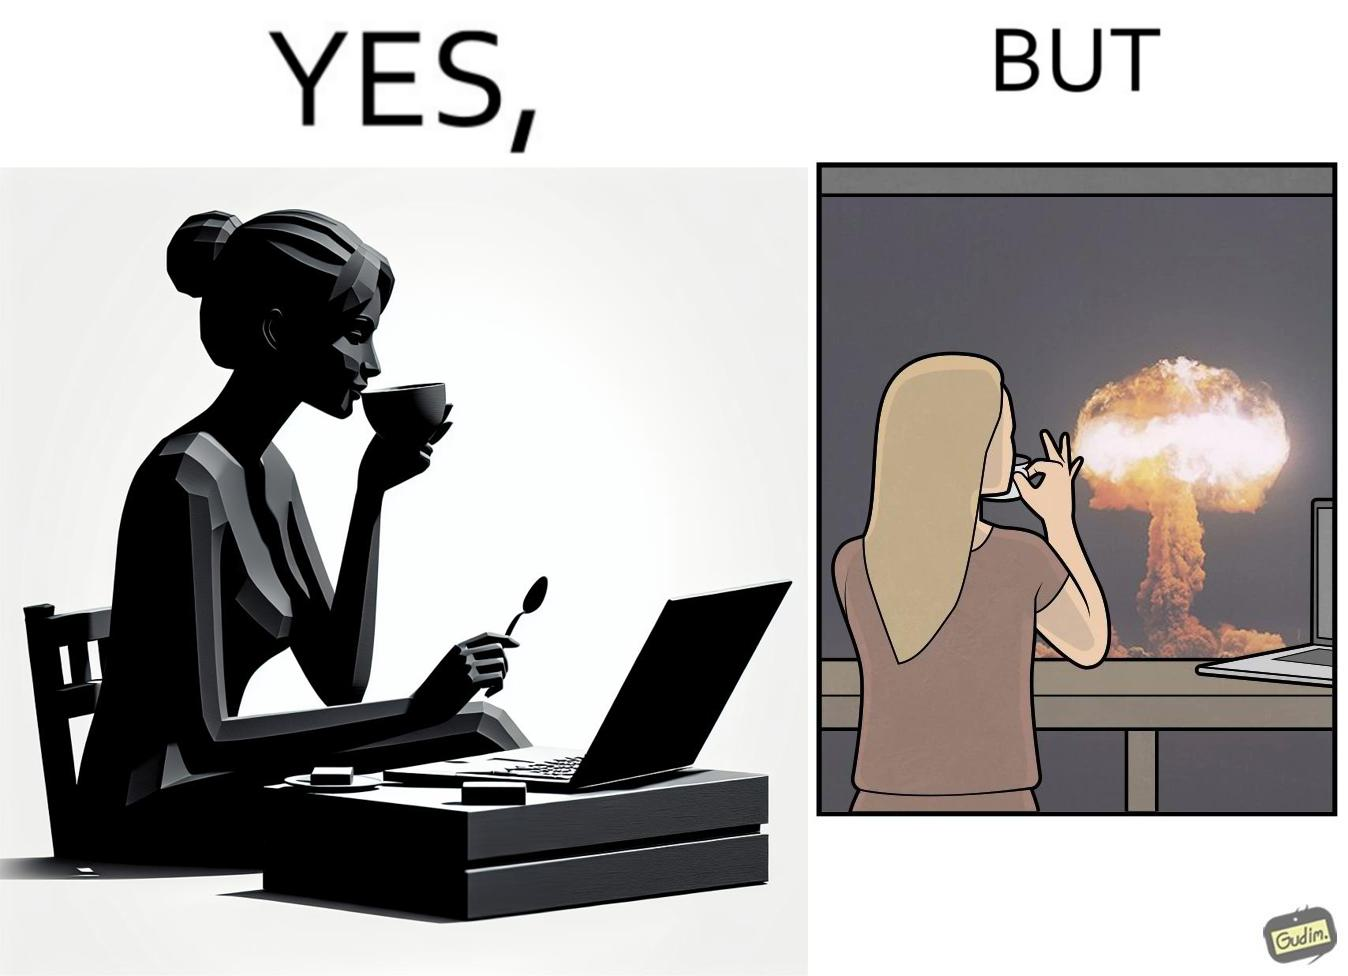What is shown in the left half versus the right half of this image? In the left part of the image: A woman sipping from a cup in a cafe with her laptop In the right part of the image: A woman sipping from a cup while looking at a nuclear blast from her desk 